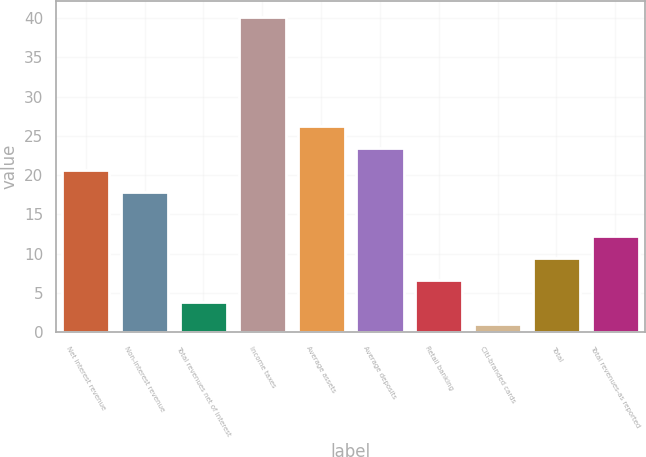Convert chart. <chart><loc_0><loc_0><loc_500><loc_500><bar_chart><fcel>Net interest revenue<fcel>Non-interest revenue<fcel>Total revenues net of interest<fcel>Income taxes<fcel>Average assets<fcel>Average deposits<fcel>Retail banking<fcel>Citi-branded cards<fcel>Total<fcel>Total revenues-as reported<nl><fcel>20.6<fcel>17.8<fcel>3.8<fcel>40.2<fcel>26.2<fcel>23.4<fcel>6.6<fcel>1<fcel>9.4<fcel>12.2<nl></chart> 